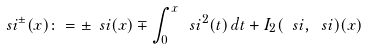<formula> <loc_0><loc_0><loc_500><loc_500>\ s i ^ { \pm } ( x ) \colon = \pm \ s i ( x ) \mp \int _ { 0 } ^ { x } \ s i ^ { 2 } ( t ) \, d t + I _ { 2 } ( \ s i , \ s i ) ( x )</formula> 